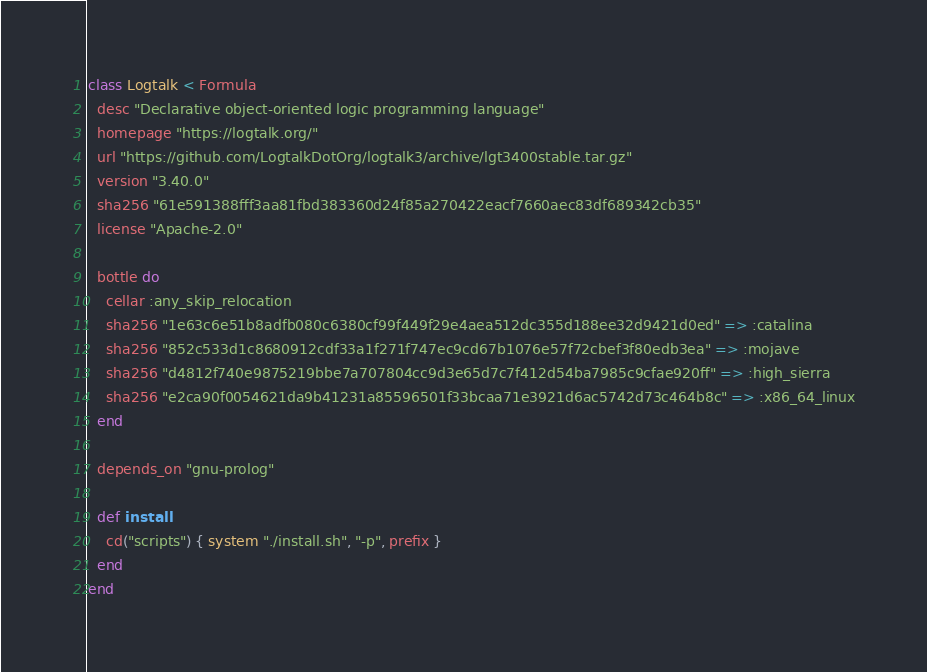Convert code to text. <code><loc_0><loc_0><loc_500><loc_500><_Ruby_>class Logtalk < Formula
  desc "Declarative object-oriented logic programming language"
  homepage "https://logtalk.org/"
  url "https://github.com/LogtalkDotOrg/logtalk3/archive/lgt3400stable.tar.gz"
  version "3.40.0"
  sha256 "61e591388fff3aa81fbd383360d24f85a270422eacf7660aec83df689342cb35"
  license "Apache-2.0"

  bottle do
    cellar :any_skip_relocation
    sha256 "1e63c6e51b8adfb080c6380cf99f449f29e4aea512dc355d188ee32d9421d0ed" => :catalina
    sha256 "852c533d1c8680912cdf33a1f271f747ec9cd67b1076e57f72cbef3f80edb3ea" => :mojave
    sha256 "d4812f740e9875219bbe7a707804cc9d3e65d7c7f412d54ba7985c9cfae920ff" => :high_sierra
    sha256 "e2ca90f0054621da9b41231a85596501f33bcaa71e3921d6ac5742d73c464b8c" => :x86_64_linux
  end

  depends_on "gnu-prolog"

  def install
    cd("scripts") { system "./install.sh", "-p", prefix }
  end
end
</code> 